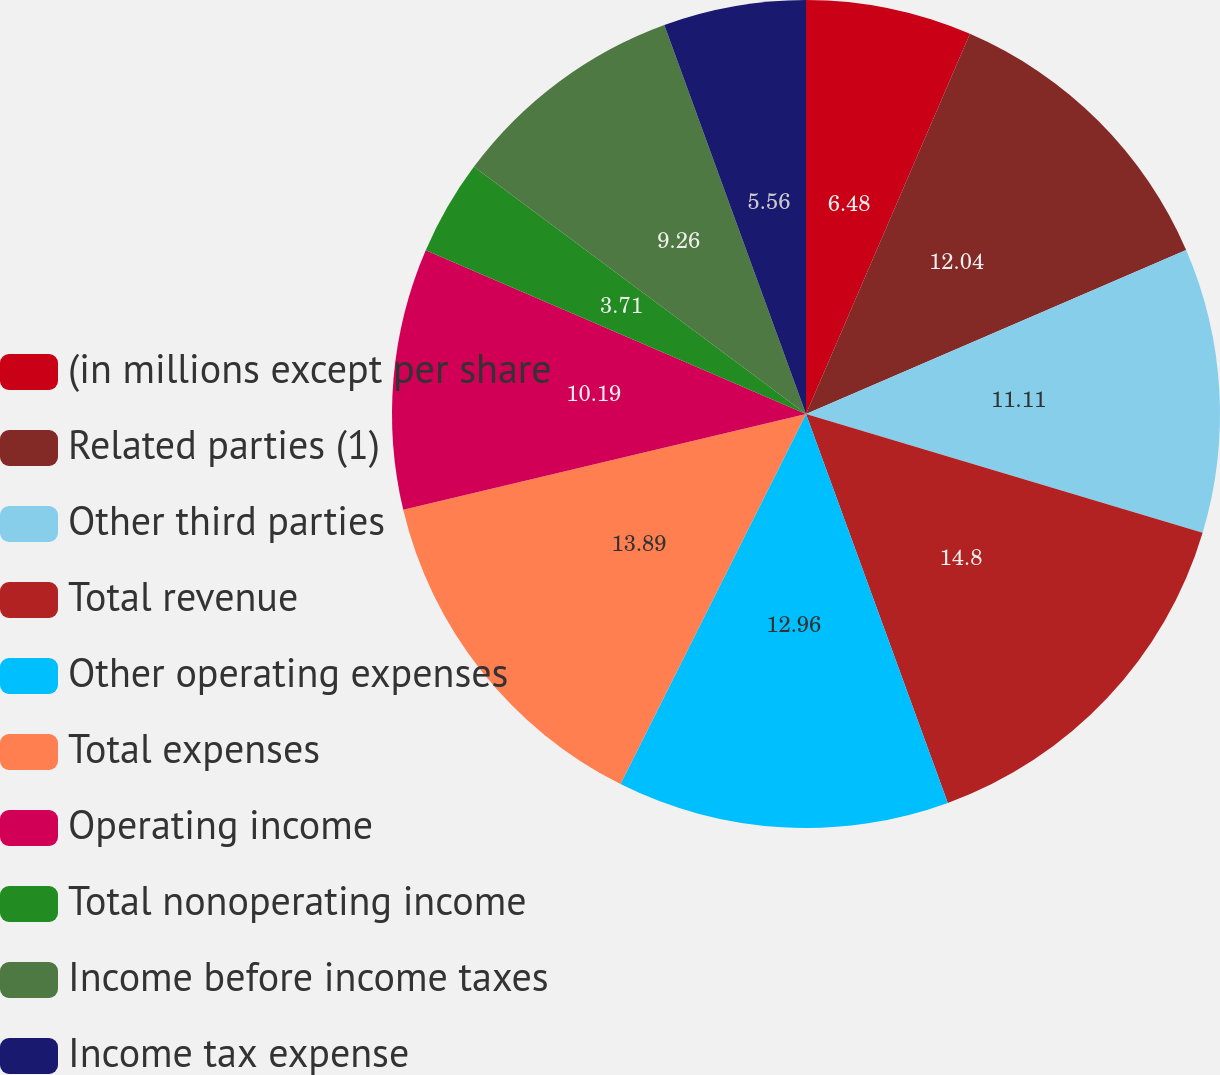Convert chart. <chart><loc_0><loc_0><loc_500><loc_500><pie_chart><fcel>(in millions except per share<fcel>Related parties (1)<fcel>Other third parties<fcel>Total revenue<fcel>Other operating expenses<fcel>Total expenses<fcel>Operating income<fcel>Total nonoperating income<fcel>Income before income taxes<fcel>Income tax expense<nl><fcel>6.48%<fcel>12.04%<fcel>11.11%<fcel>14.81%<fcel>12.96%<fcel>13.89%<fcel>10.19%<fcel>3.71%<fcel>9.26%<fcel>5.56%<nl></chart> 